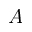Convert formula to latex. <formula><loc_0><loc_0><loc_500><loc_500>A</formula> 